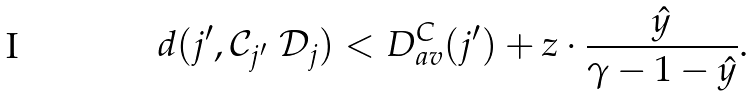Convert formula to latex. <formula><loc_0><loc_0><loc_500><loc_500>d ( j ^ { \prime } , \mathcal { C } _ { j ^ { \prime } } \ \mathcal { D } _ { j } ) < D _ { a v } ^ { C } ( j ^ { \prime } ) + z \cdot \frac { \hat { y } } { \gamma - 1 - \hat { y } } .</formula> 